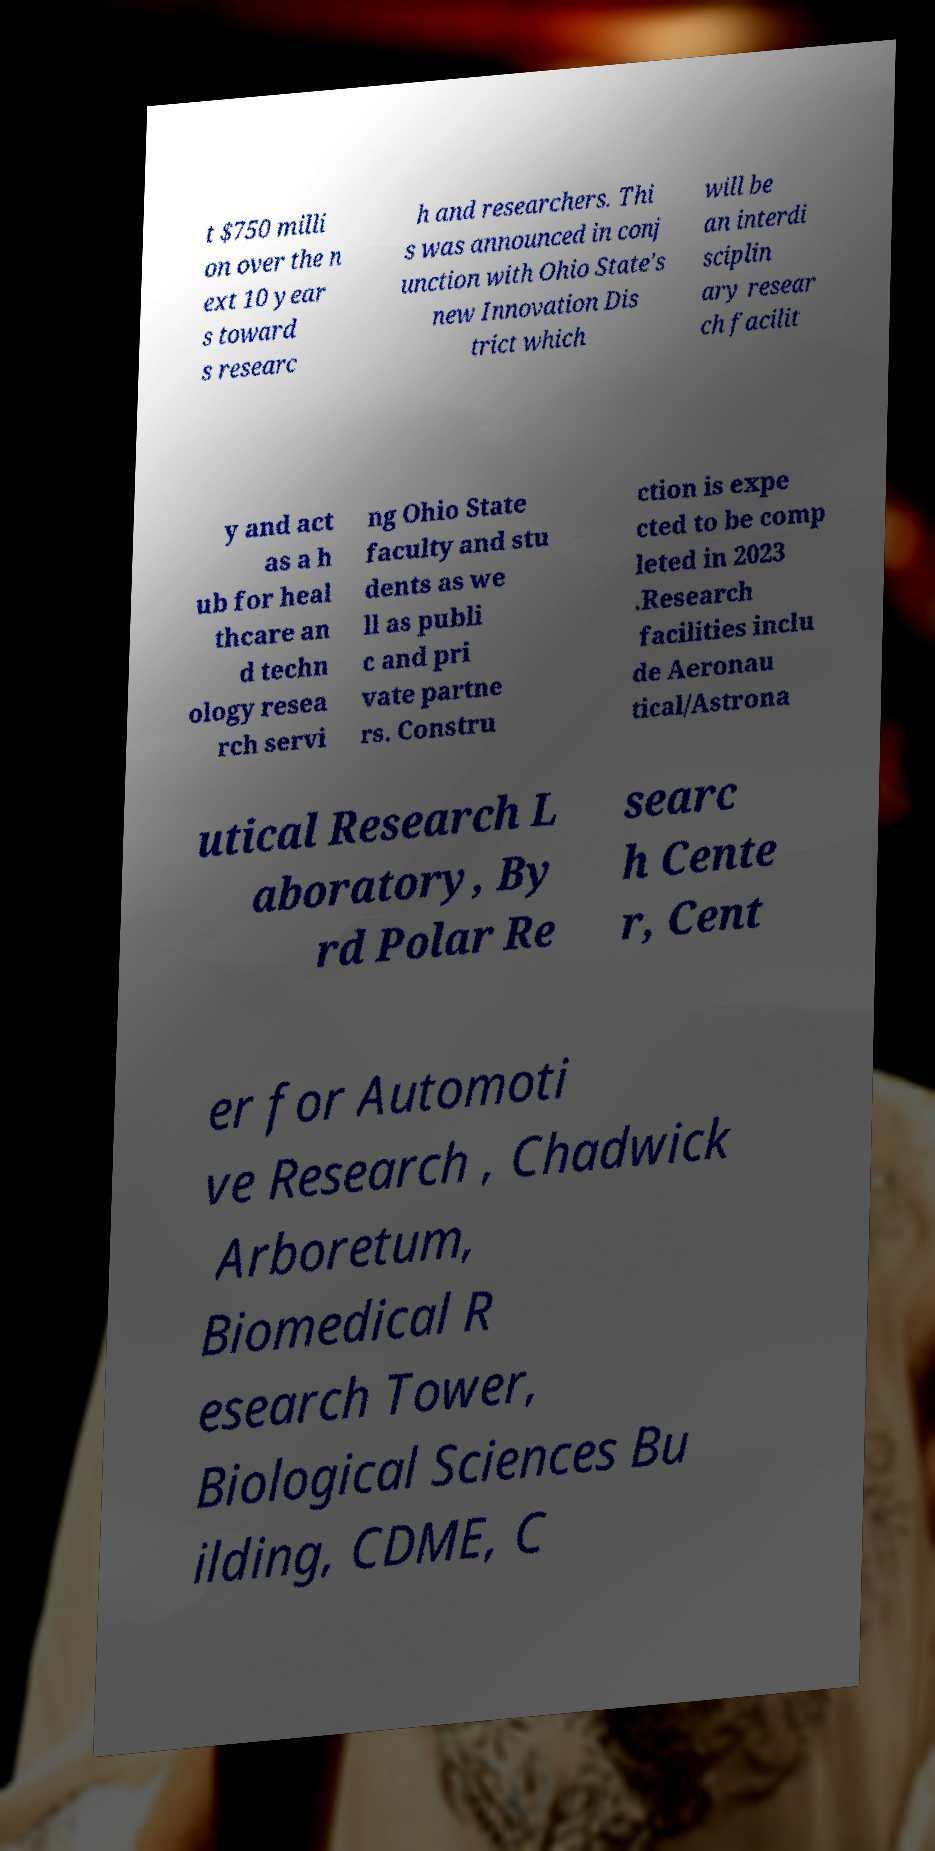For documentation purposes, I need the text within this image transcribed. Could you provide that? t $750 milli on over the n ext 10 year s toward s researc h and researchers. Thi s was announced in conj unction with Ohio State's new Innovation Dis trict which will be an interdi sciplin ary resear ch facilit y and act as a h ub for heal thcare an d techn ology resea rch servi ng Ohio State faculty and stu dents as we ll as publi c and pri vate partne rs. Constru ction is expe cted to be comp leted in 2023 .Research facilities inclu de Aeronau tical/Astrona utical Research L aboratory, By rd Polar Re searc h Cente r, Cent er for Automoti ve Research , Chadwick Arboretum, Biomedical R esearch Tower, Biological Sciences Bu ilding, CDME, C 